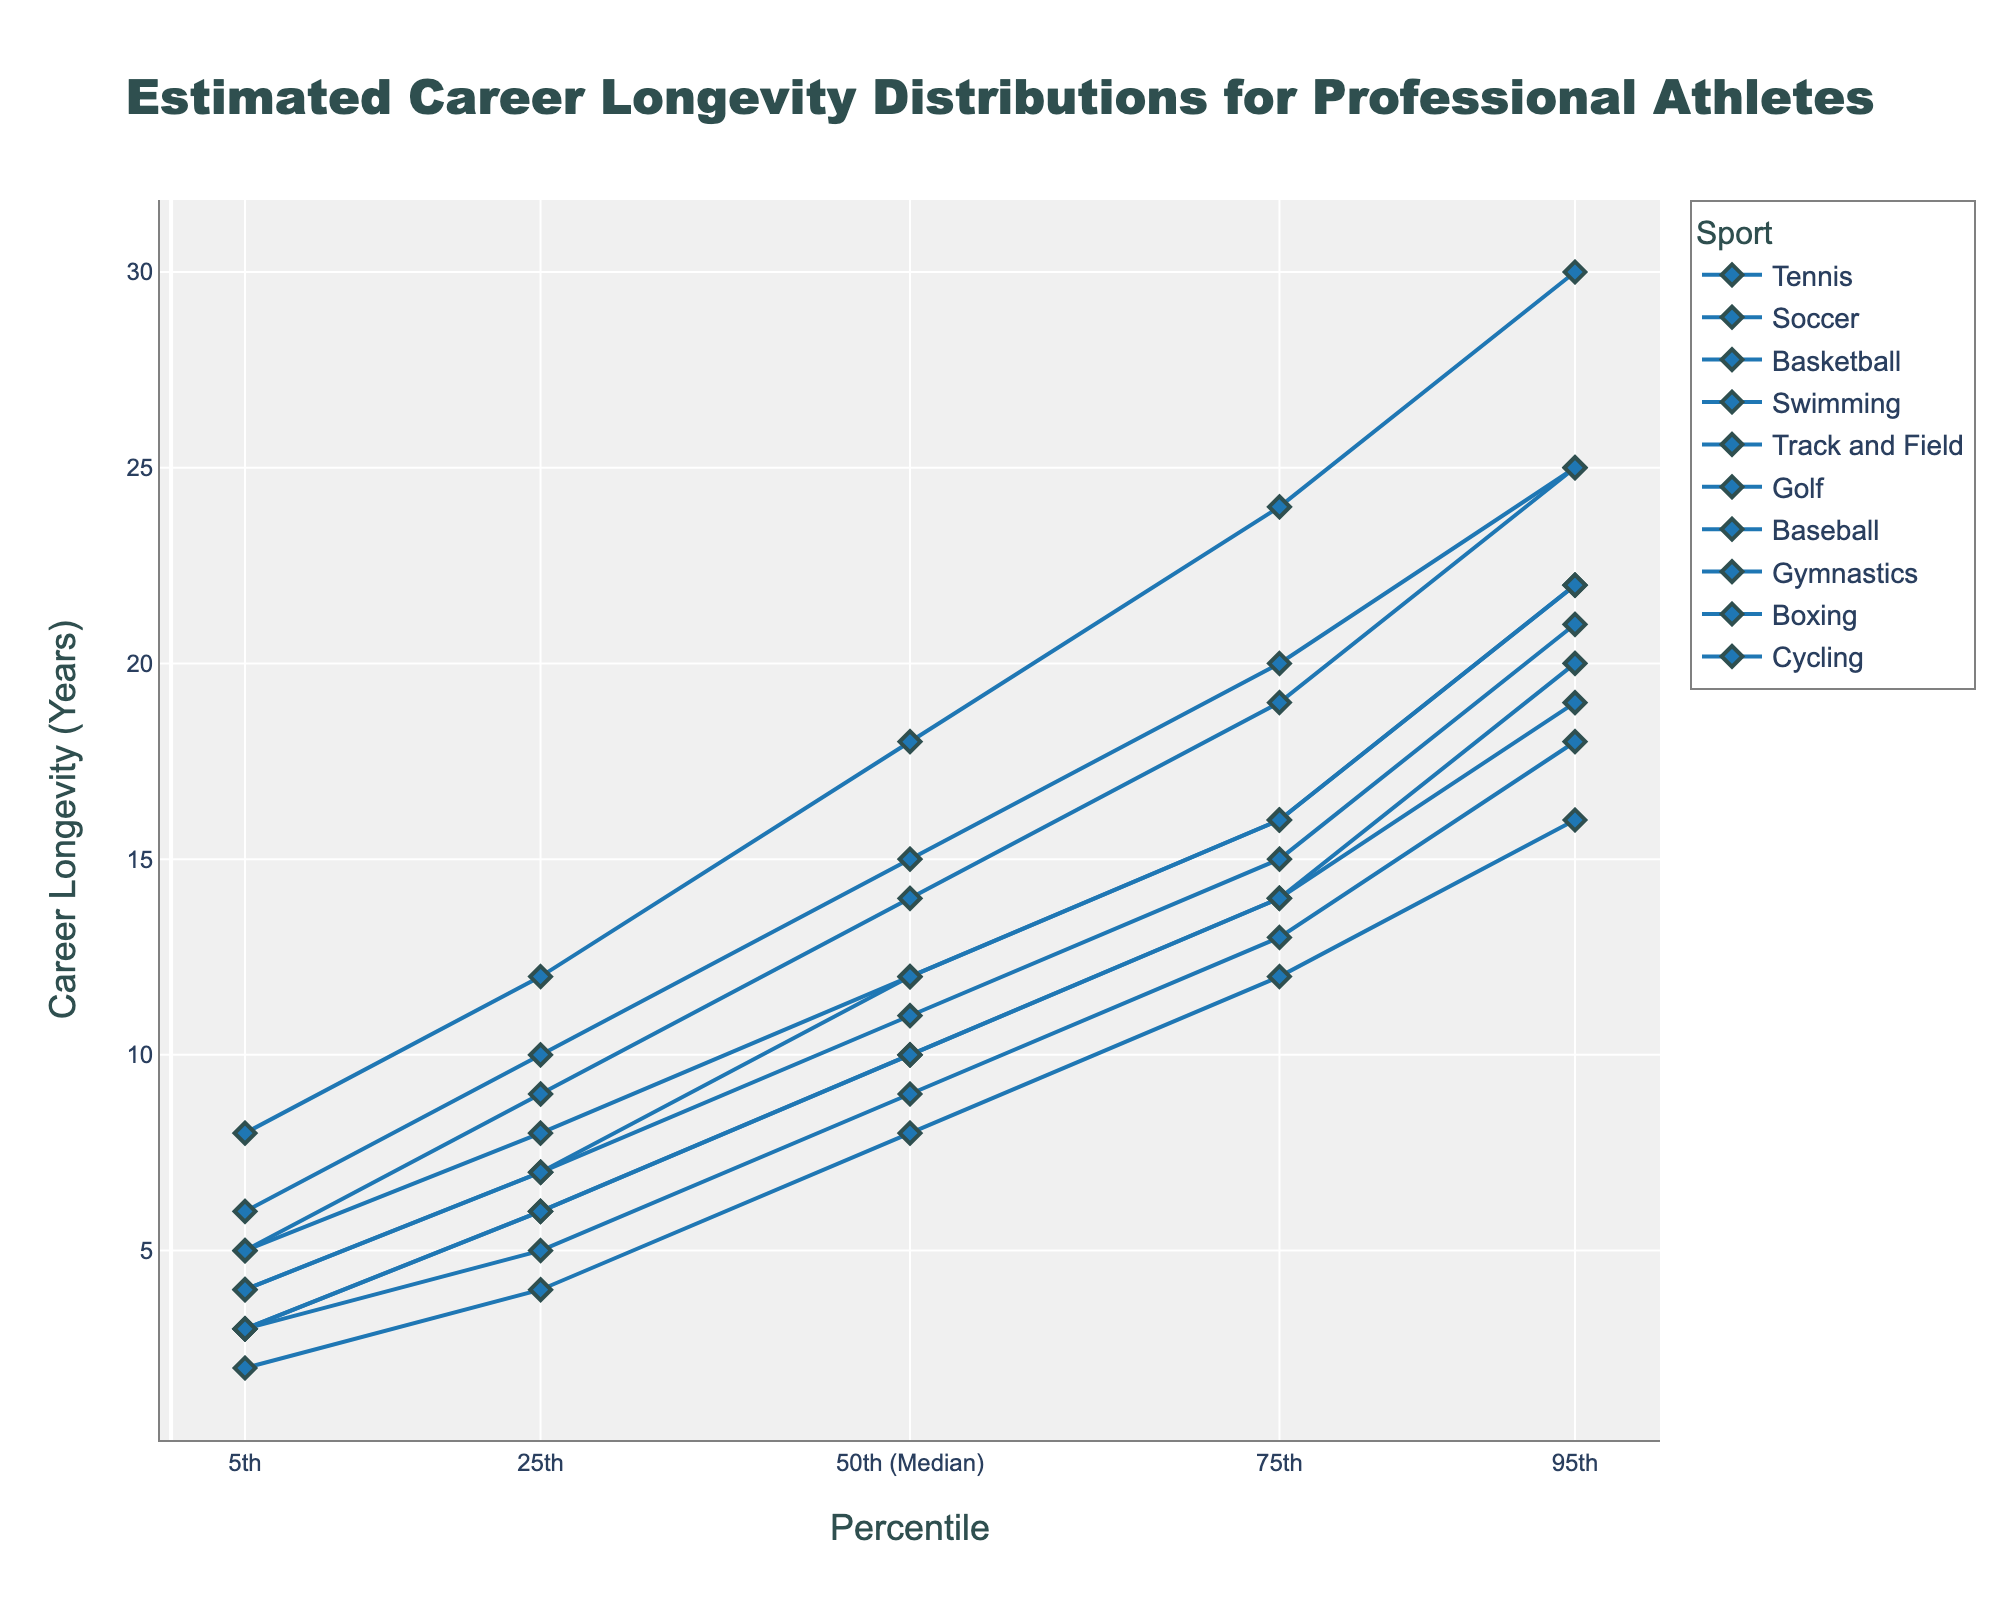What's the title of the chart? The chart's title is usually displayed at the top of the figure. In this case, it reads "Estimated Career Longevity Distributions for Professional Athletes".
Answer: Estimated Career Longevity Distributions for Professional Athletes What are the axis titles? The x-axis title is "Percentile" and the y-axis title is "Career Longevity (Years)".
Answer: Percentile, Career Longevity (Years) Which sport has the highest median career longevity? By looking at the median values on the y-axis, "Golf" has the highest median career longevity at 18 years.
Answer: Golf At the 5th percentile, which sport has the shortest career longevity? The 5th percentile values show that "Gymnastics" has the shortest career longevity at 2 years.
Answer: Gymnastics How many sports have a career longevity of 12 years at the 75th percentile? The values at the 75th percentile indicate that "Soccer", "Track and Field", and "Gymnastics" have career longevity of 12 years.
Answer: Three What is the range of career longevity for Cycling at the 25th to 75th percentiles? The 25th percentile for Cycling is 9 years, and the 75th percentile is 19 years, making the range 19 - 9 = 10 years.
Answer: 10 years Which sport shows the widest spread between the 5th and 95th percentiles? By comparing the spreads, Cycling shows the widest spread from 5 years at the 5th percentile to 25 years at the 95th percentile.
Answer: Cycling Compare the median career longevity of Tennis and Basketball. Which one is higher and by how much? Tennis has a median of 10 years and Basketball has a median of 9 years. The difference is 10 - 9 = 1 year.
Answer: Tennis, by 1 year What is the interquartile range (IQR) of career longevity for Swimming? The IQR is calculated by subtracting the 25th percentile from the 75th percentile. For Swimming, this is 20 - 10 = 10 years.
Answer: 10 years Does any sport have the same career longevity at both the 75th and 95th percentiles? By examining the values at both percentiles, no sport has the same career longevity at the 75th and 95th percentiles.
Answer: No 